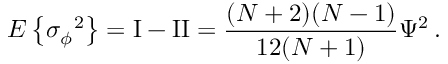<formula> <loc_0><loc_0><loc_500><loc_500>E \left \{ \sigma { _ { \phi } } ^ { 2 } \right \} = I - I I = { \frac { ( N + 2 ) ( N - 1 ) } { 1 2 ( N + 1 ) } } \Psi ^ { 2 } \, .</formula> 